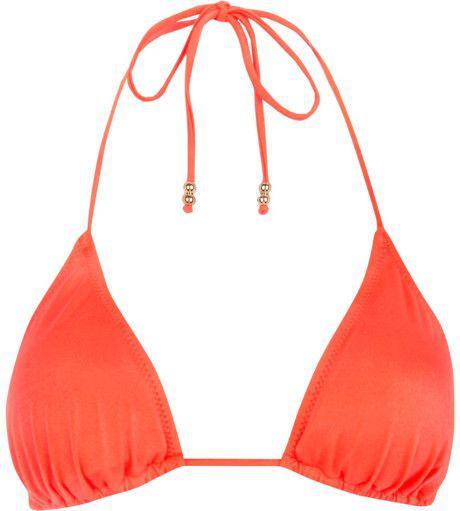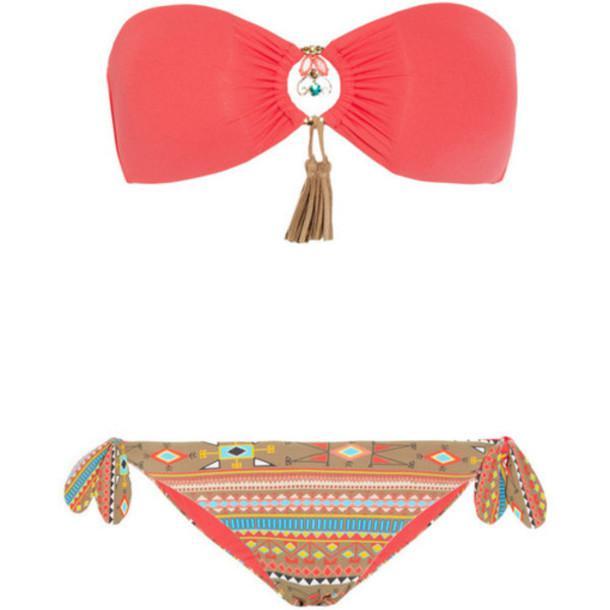The first image is the image on the left, the second image is the image on the right. Evaluate the accuracy of this statement regarding the images: "Only the right image shows a bikini top and bottom.". Is it true? Answer yes or no. Yes. 